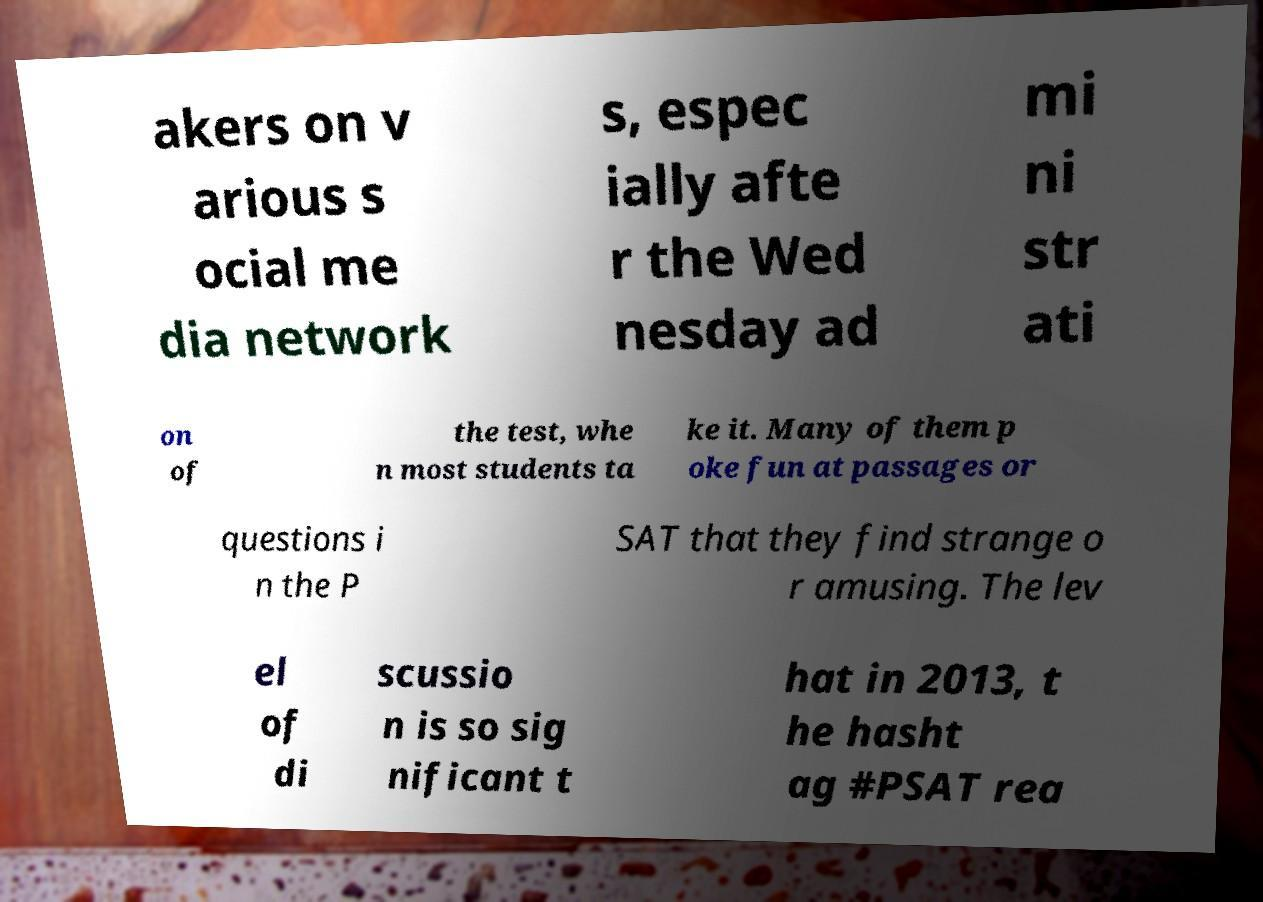Could you extract and type out the text from this image? akers on v arious s ocial me dia network s, espec ially afte r the Wed nesday ad mi ni str ati on of the test, whe n most students ta ke it. Many of them p oke fun at passages or questions i n the P SAT that they find strange o r amusing. The lev el of di scussio n is so sig nificant t hat in 2013, t he hasht ag #PSAT rea 